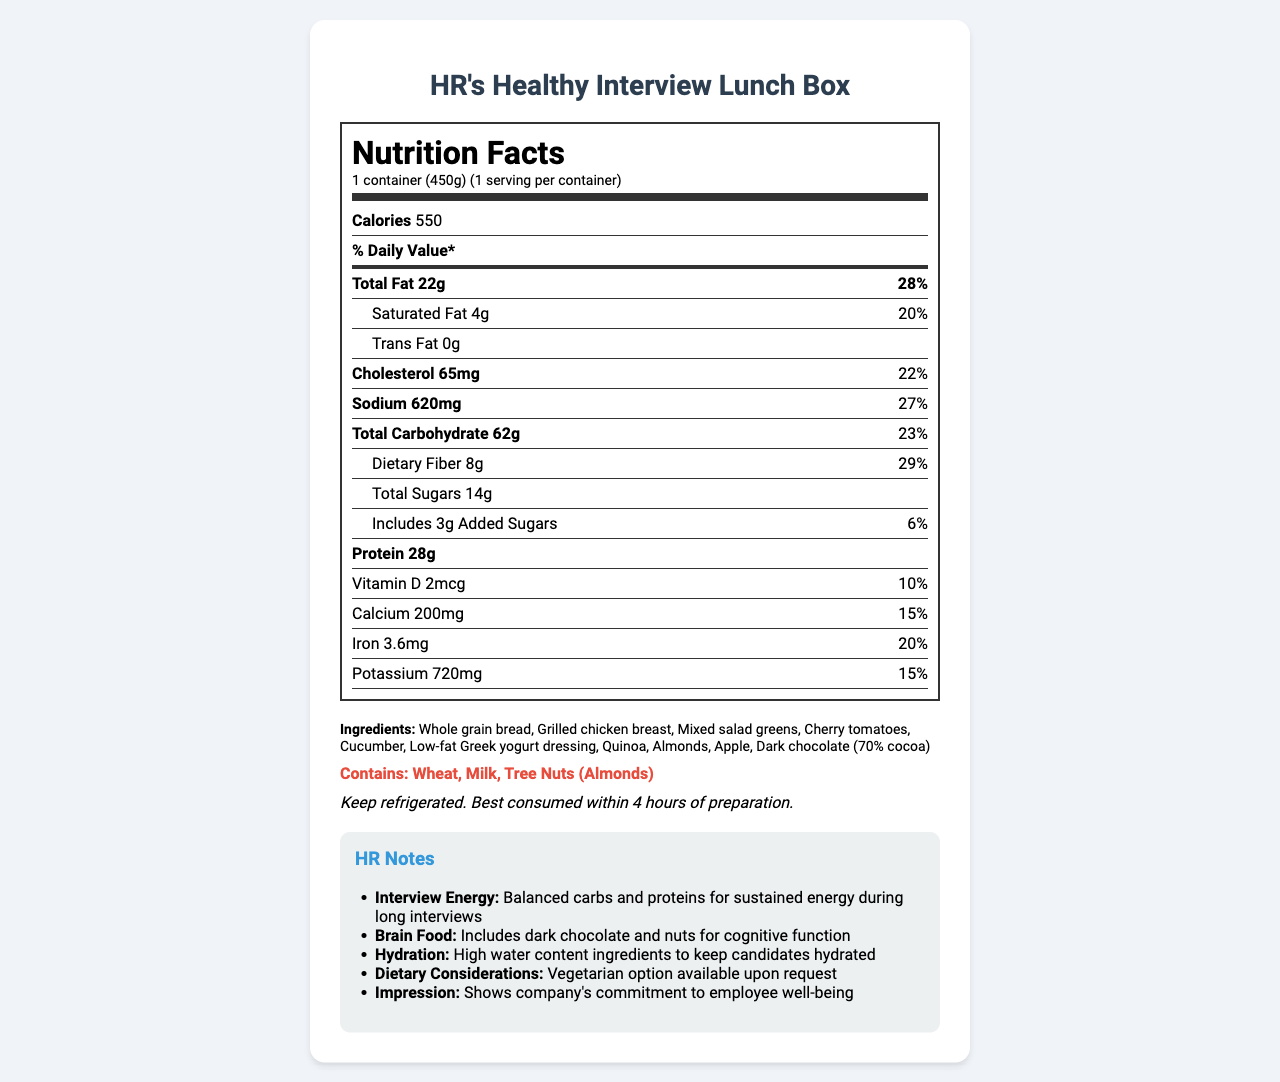What is the calorie count of HR's Healthy Interview Lunch Box? The document indicates that the lunch box contains 550 calories.
Answer: 550 How much protein does the lunch box contain per serving? The protein content is listed as 28 grams per container.
Answer: 28g What is the percentage of daily value for calcium? The document states that the calcium daily value is 15%.
Answer: 15% How many grams of dietary fiber are in the lunch box? The dietary fiber content is listed as 8 grams.
Answer: 8g What are the allergens mentioned in the document? The document explicitly lists wheat, milk, and tree nuts (almonds) as allergens.
Answer: Wheat, Milk, Tree Nuts (Almonds) Which ingredient is not listed in the lunch box? A. Cherry tomatoes B. Red peppers C. Quinoa The ingredients listed are whole grain bread, grilled chicken breast, mixed salad greens, cherry tomatoes, cucumber, low-fat Greek yogurt dressing, quinoa, almonds, apple, and dark chocolate. Red peppers are not included.
Answer: B. Red peppers What is the serving size of the lunch box? The serving size is clearly indicated as 1 container (450g).
Answer: 1 container (450g) What is the daily value percentage of sodium? The sodium daily value percentage is listed as 27%.
Answer: 27% Which ingredient could help with cognitive function? A. Apple B. Greek yogurt C. Dark chocolate The HR notes mention that dark chocolate is included for cognitive function.
Answer: C. Dark chocolate Does the lunch box include added sugars? The document shows 3g of added sugars with a daily value of 6%.
Answer: Yes Describe the main idea of the document. The document includes comprehensive nutritional facts such as calories and nutrient breakdown, ingredients, allergens, preparation instructions, and HR notes emphasizing the box's energy sustainability, cognitive benefits, hydration, and overall impression.
Answer: The document provides the nutritional information for "HR's Healthy Interview Lunch Box," including serving size, calories, and a breakdown of various nutrients. It also lists ingredients, allergens, preparation instructions, and HR notes explaining the lunch box's benefits for interview candidates. Can the total fat content meet half of the daily value percentage? The total fat content is 22 grams, which is 28% of the daily value, not half (50%).
Answer: No How much iron is in the lunch box? The document lists the iron content as 3.6 milligrams.
Answer: 3.6mg What is the preparation instruction for the lunch box? The document instructs to keep the lunch box refrigerated and consume it within 4 hours of preparation.
Answer: Keep refrigerated. Best consumed within 4 hours of preparation. What is the brain food ingredient mentioned in the HR notes? The HR notes specifically mention dark chocolate and nuts as brain food for cognitive function.
Answer: Dark chocolate and nuts Are there any vegetarian options available? The HR notes mention that a vegetarian option is available upon request.
Answer: Yes Was this lunch box prepared by a specific chef? The document does not provide any information about who prepared the lunch box.
Answer: Cannot be determined 